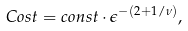Convert formula to latex. <formula><loc_0><loc_0><loc_500><loc_500>C o s t = c o n s t \cdot { \epsilon ^ { - ( 2 + 1 / \nu ) } } ,</formula> 